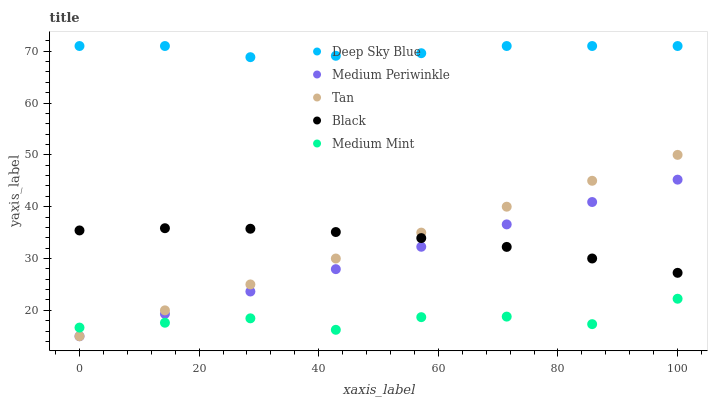Does Medium Mint have the minimum area under the curve?
Answer yes or no. Yes. Does Deep Sky Blue have the maximum area under the curve?
Answer yes or no. Yes. Does Black have the minimum area under the curve?
Answer yes or no. No. Does Black have the maximum area under the curve?
Answer yes or no. No. Is Tan the smoothest?
Answer yes or no. Yes. Is Medium Mint the roughest?
Answer yes or no. Yes. Is Black the smoothest?
Answer yes or no. No. Is Black the roughest?
Answer yes or no. No. Does Tan have the lowest value?
Answer yes or no. Yes. Does Black have the lowest value?
Answer yes or no. No. Does Deep Sky Blue have the highest value?
Answer yes or no. Yes. Does Black have the highest value?
Answer yes or no. No. Is Medium Mint less than Black?
Answer yes or no. Yes. Is Deep Sky Blue greater than Black?
Answer yes or no. Yes. Does Tan intersect Medium Periwinkle?
Answer yes or no. Yes. Is Tan less than Medium Periwinkle?
Answer yes or no. No. Is Tan greater than Medium Periwinkle?
Answer yes or no. No. Does Medium Mint intersect Black?
Answer yes or no. No. 